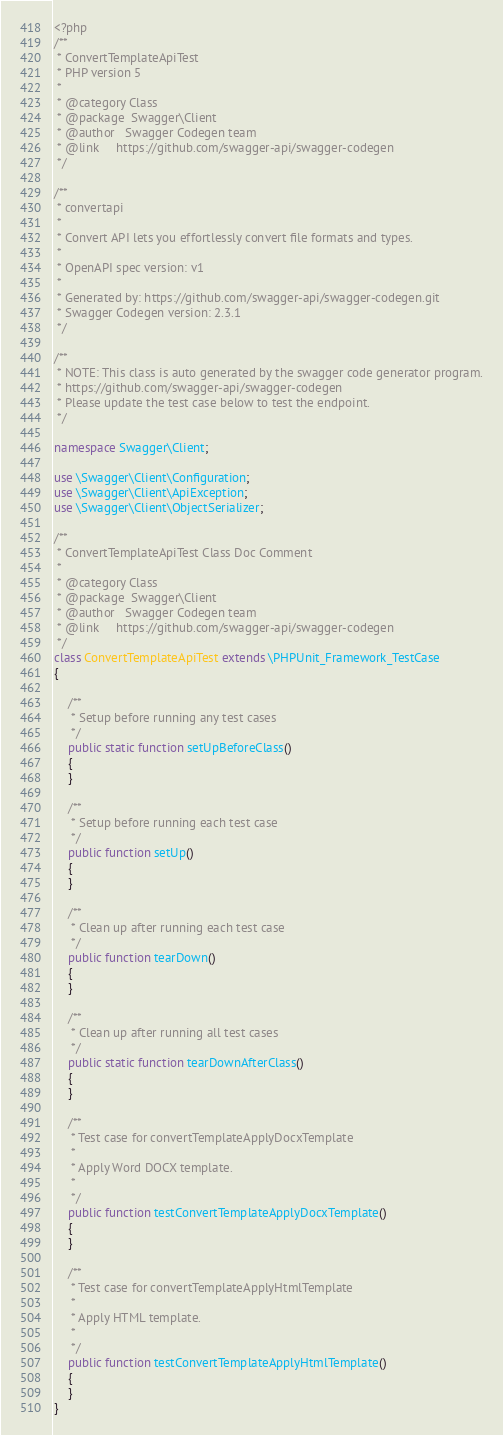<code> <loc_0><loc_0><loc_500><loc_500><_PHP_><?php
/**
 * ConvertTemplateApiTest
 * PHP version 5
 *
 * @category Class
 * @package  Swagger\Client
 * @author   Swagger Codegen team
 * @link     https://github.com/swagger-api/swagger-codegen
 */

/**
 * convertapi
 *
 * Convert API lets you effortlessly convert file formats and types.
 *
 * OpenAPI spec version: v1
 * 
 * Generated by: https://github.com/swagger-api/swagger-codegen.git
 * Swagger Codegen version: 2.3.1
 */

/**
 * NOTE: This class is auto generated by the swagger code generator program.
 * https://github.com/swagger-api/swagger-codegen
 * Please update the test case below to test the endpoint.
 */

namespace Swagger\Client;

use \Swagger\Client\Configuration;
use \Swagger\Client\ApiException;
use \Swagger\Client\ObjectSerializer;

/**
 * ConvertTemplateApiTest Class Doc Comment
 *
 * @category Class
 * @package  Swagger\Client
 * @author   Swagger Codegen team
 * @link     https://github.com/swagger-api/swagger-codegen
 */
class ConvertTemplateApiTest extends \PHPUnit_Framework_TestCase
{

    /**
     * Setup before running any test cases
     */
    public static function setUpBeforeClass()
    {
    }

    /**
     * Setup before running each test case
     */
    public function setUp()
    {
    }

    /**
     * Clean up after running each test case
     */
    public function tearDown()
    {
    }

    /**
     * Clean up after running all test cases
     */
    public static function tearDownAfterClass()
    {
    }

    /**
     * Test case for convertTemplateApplyDocxTemplate
     *
     * Apply Word DOCX template.
     *
     */
    public function testConvertTemplateApplyDocxTemplate()
    {
    }

    /**
     * Test case for convertTemplateApplyHtmlTemplate
     *
     * Apply HTML template.
     *
     */
    public function testConvertTemplateApplyHtmlTemplate()
    {
    }
}
</code> 